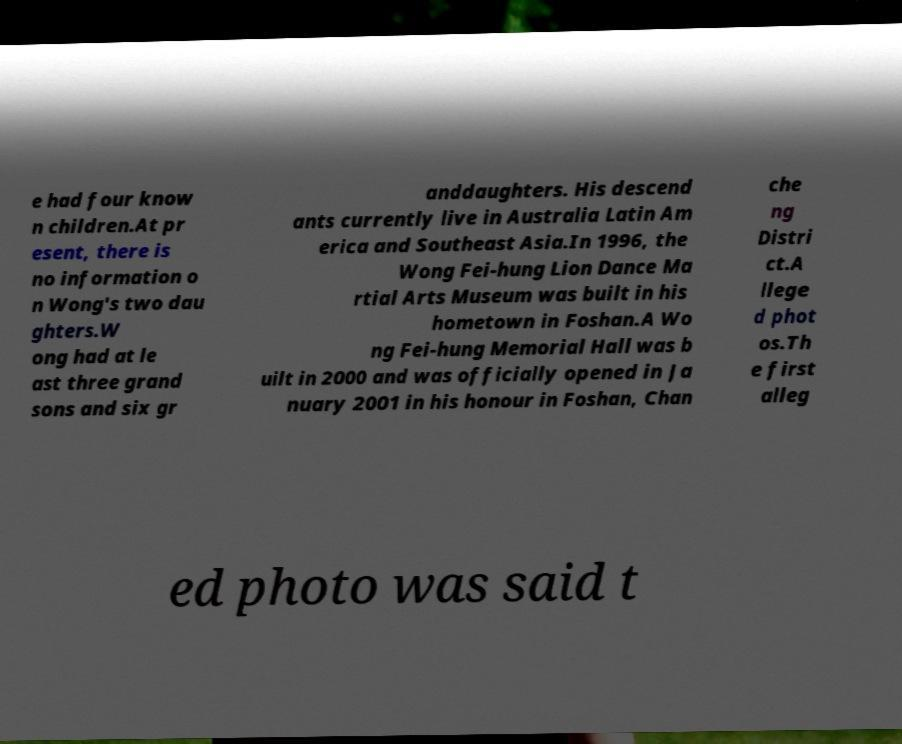Can you accurately transcribe the text from the provided image for me? e had four know n children.At pr esent, there is no information o n Wong's two dau ghters.W ong had at le ast three grand sons and six gr anddaughters. His descend ants currently live in Australia Latin Am erica and Southeast Asia.In 1996, the Wong Fei-hung Lion Dance Ma rtial Arts Museum was built in his hometown in Foshan.A Wo ng Fei-hung Memorial Hall was b uilt in 2000 and was officially opened in Ja nuary 2001 in his honour in Foshan, Chan che ng Distri ct.A llege d phot os.Th e first alleg ed photo was said t 